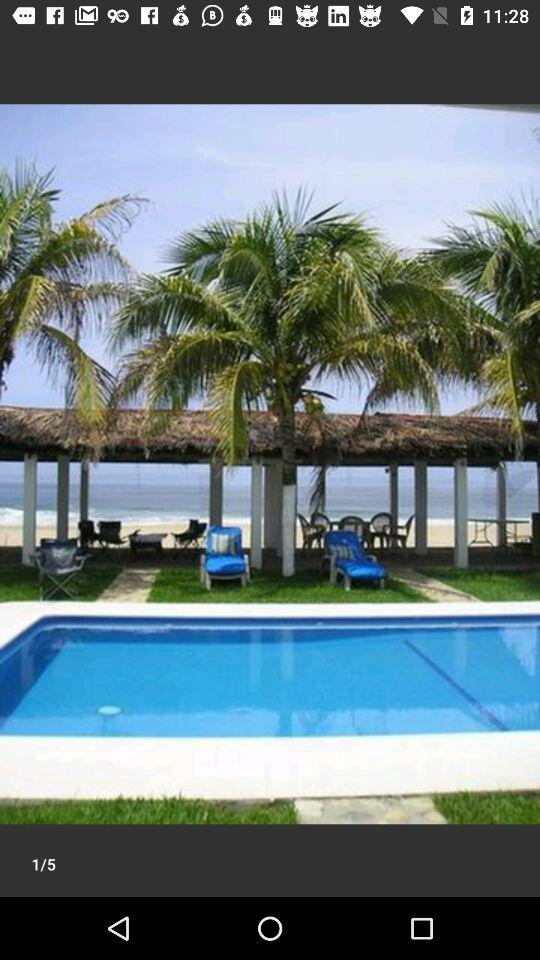How many images are there in total? There are 5 images in total. 